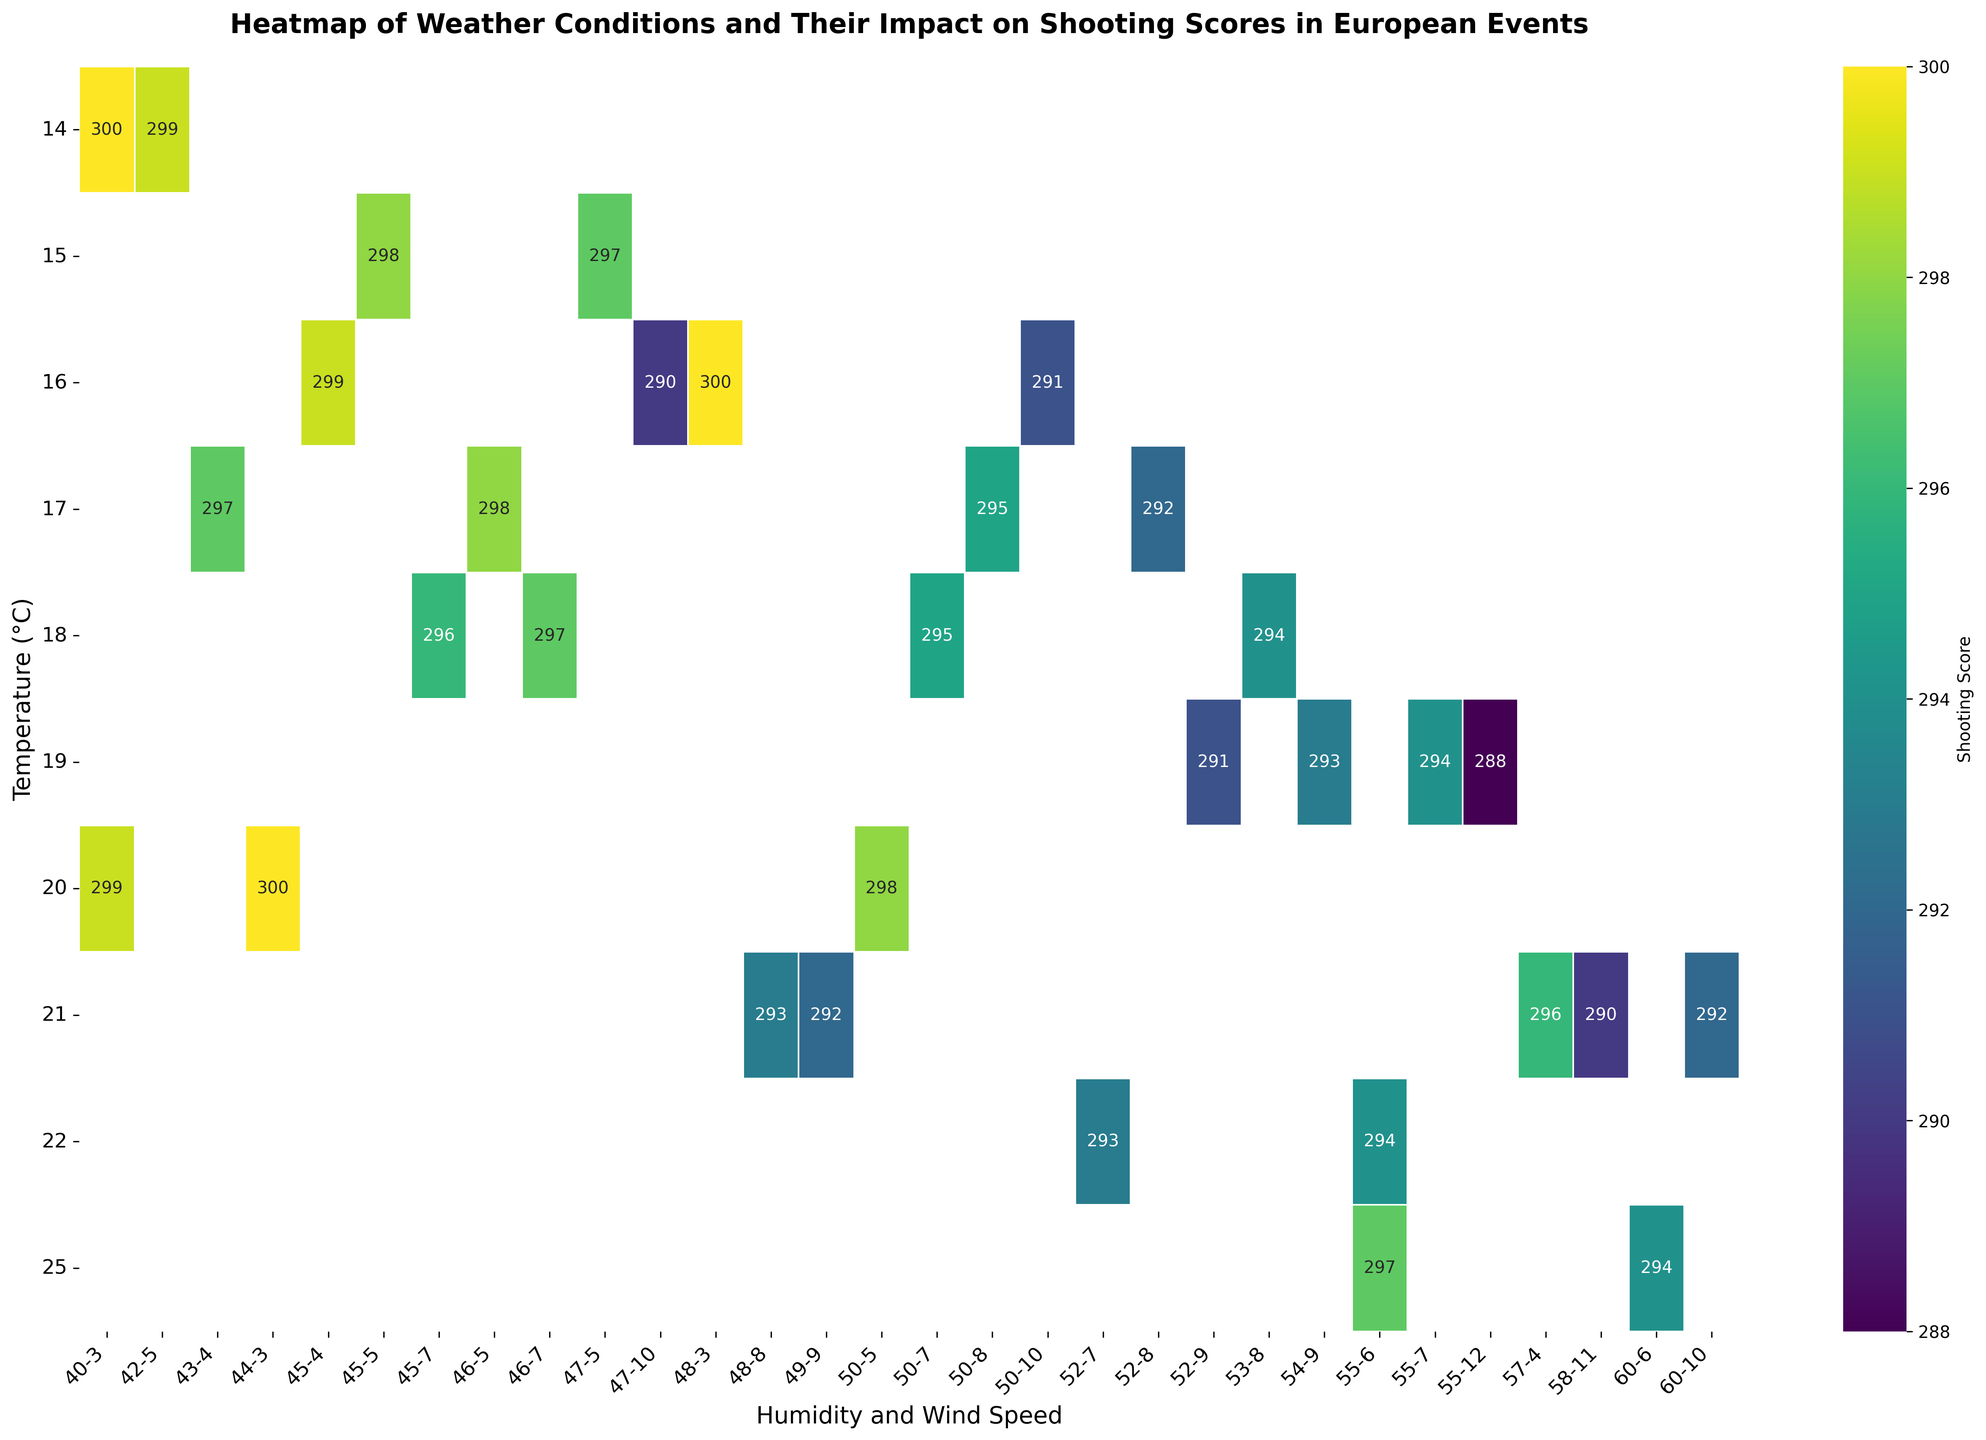Which temperature shows the highest average shooting score? Identify the row with the darkest (highest value) color in the heatmap. It shows that temperature 14°C has the highest average shooting score.
Answer: 14°C What is the average shooting score for temperatures of 21°C across different humidity and wind speed levels? Locate the row corresponding to temperature 21°C and find the average of all the scores in that row. The values are 290, 292, 293, 294, 297, and 298. The average is (290 + 292 + 293 + 294 + 297 + 298) / 6 = 1774 / 6 = 295.67.
Answer: 295.67 Which humidity and wind speed combination leads to the highest shooting score for a temperature of 20°C in the figure? Find the row for temperature 20°C and look for the combination of humidity and wind speed with the darkest color. The combination is 40% humidity and 3 m/s wind speed, corresponding to a score of 299.
Answer: Humidity 40%, Wind Speed 3 m/s Is the shooting score generally higher at lower wind speeds within the same temperature range? Compare the scores along the rows for different wind speeds within the same temperature. For most temperatures, scores tend to be higher at lower wind speeds, indicating lower wind speed generally results in higher shooting scores.
Answer: Yes What's the range of shooting scores for temperatures of 18°C across different humidity and wind speed levels? Find the row corresponding to temperature 18°C and identify the smallest and largest values in that row. The values range from 294 to 297. The range is 297 - 294 = 3.
Answer: 3 For a temperature of 19°C, which combination of humidity and wind speed yields the lowest shooting score? Locate the row for temperature 19°C, then identify the cell with the lightest (lowest value) color. The combination is 55% humidity and 12 m/s wind speed, with a score of 288.
Answer: Humidity 55%, Wind Speed 12 m/s At 15°C, is the shooting score more dependent on humidity or wind speed? Examine the scores at 15°C temperature under different humidity and wind speed levels. Compare the variation in scores due to changes in humidity versus changes in wind speed. There is relatively less variation with changes in humidity compared to changes in wind speed, indicating greater dependence on wind speed.
Answer: Wind Speed What is the total shooting score for the given temperature of 17°C across all humidity and wind speed levels displayed? Sum all shooting scores for the row corresponding to 17°C. The values are 295, 297, 292, 295, and 298. The total is 295 + 297 + 292 + 295 + 298 = 1477.
Answer: 1477 How does the shooting score at 25°C and 55% humidity compare to the score at 25°C and 60% humidity? Identify the scores for both humidity levels at 25°C. The score at 55% humidity is 297, and at 60% humidity is 294. Comparing the scores, 297 is greater than 294.
Answer: 297 is greater than 294 